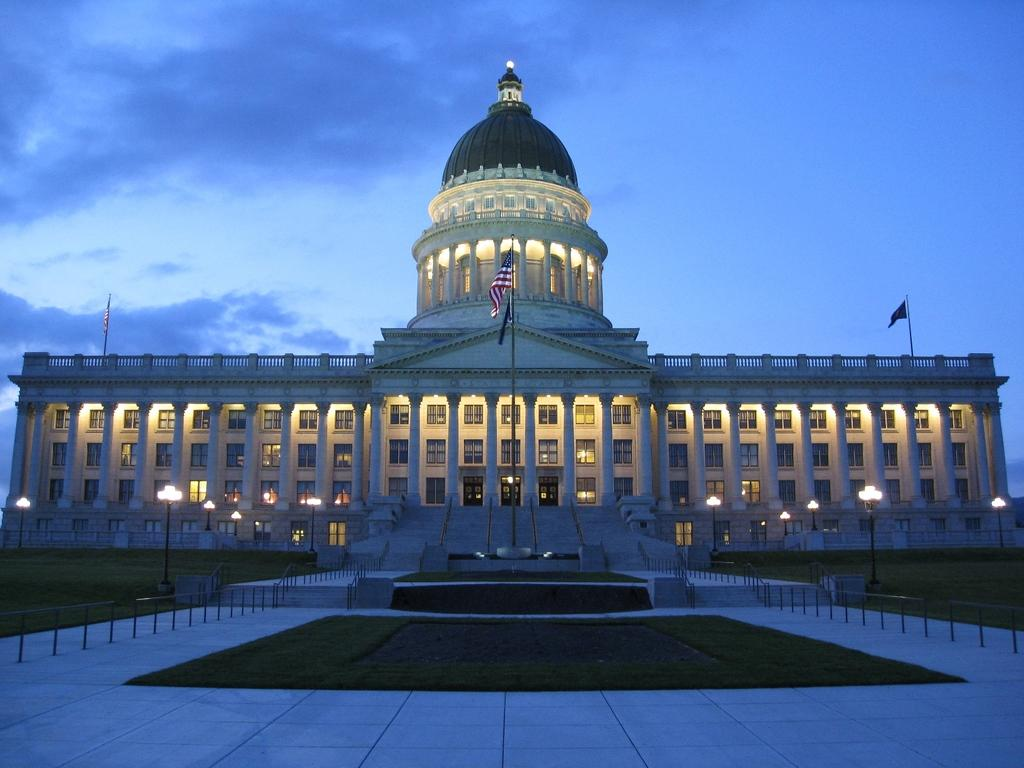What type of surface covers the ground in the image? The ground in the image is covered with grass. What architectural feature can be seen in the image? There are stairs in the image. What type of structure is present in the image? There is a building in the image. What type of lighting is present in the image? There are street light poles in the image. What decorative elements are present in the image? There are flags in the image. How would you describe the weather in the image? The sky is cloudy in the image. What type of error can be seen in the image? There is no error present in the image. What letters are visible on the flags in the image? There are no letters visible on the flags in the image; only the flag designs can be seen. 